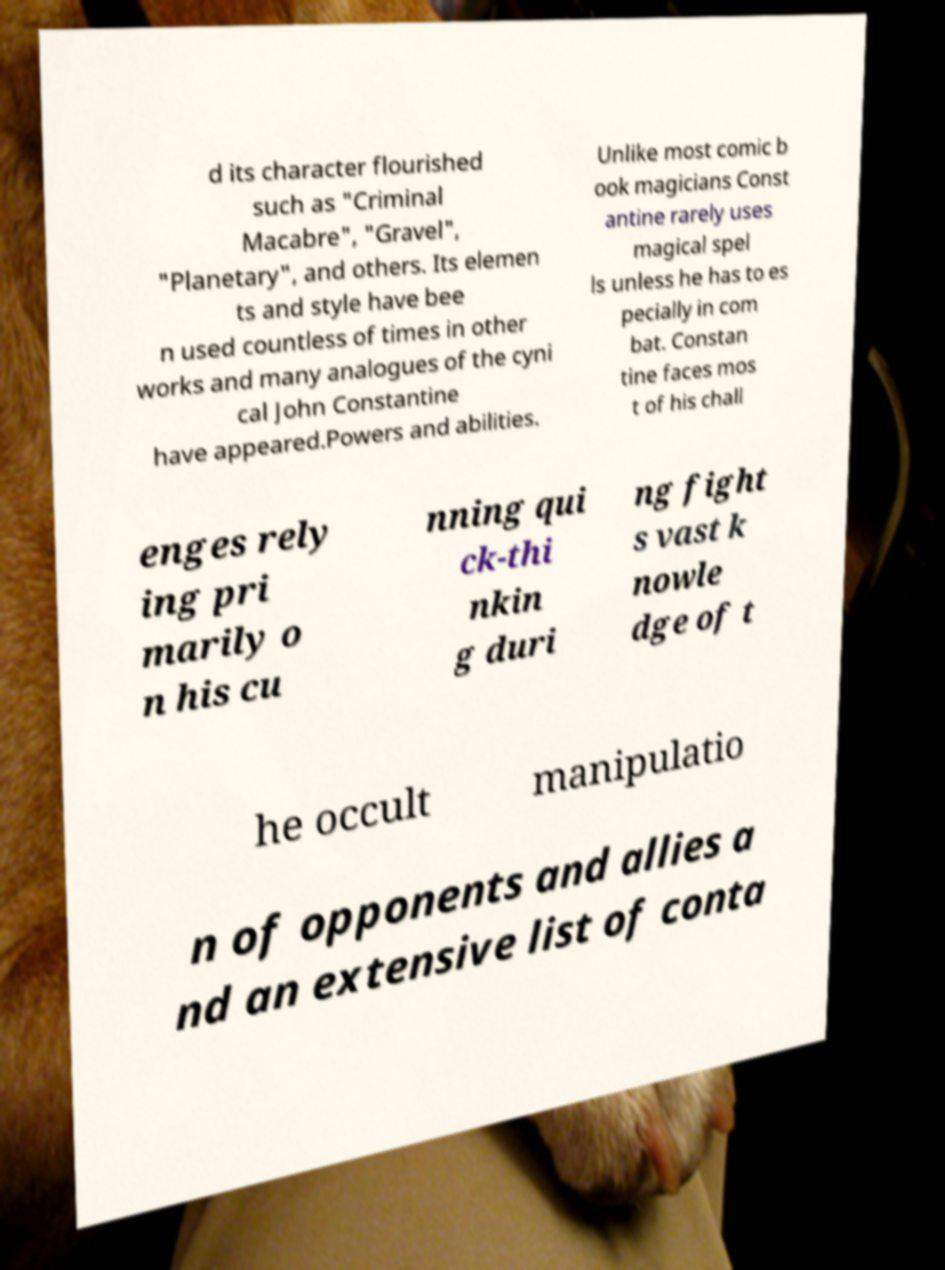Please identify and transcribe the text found in this image. d its character flourished such as "Criminal Macabre", "Gravel", "Planetary", and others. Its elemen ts and style have bee n used countless of times in other works and many analogues of the cyni cal John Constantine have appeared.Powers and abilities. Unlike most comic b ook magicians Const antine rarely uses magical spel ls unless he has to es pecially in com bat. Constan tine faces mos t of his chall enges rely ing pri marily o n his cu nning qui ck-thi nkin g duri ng fight s vast k nowle dge of t he occult manipulatio n of opponents and allies a nd an extensive list of conta 